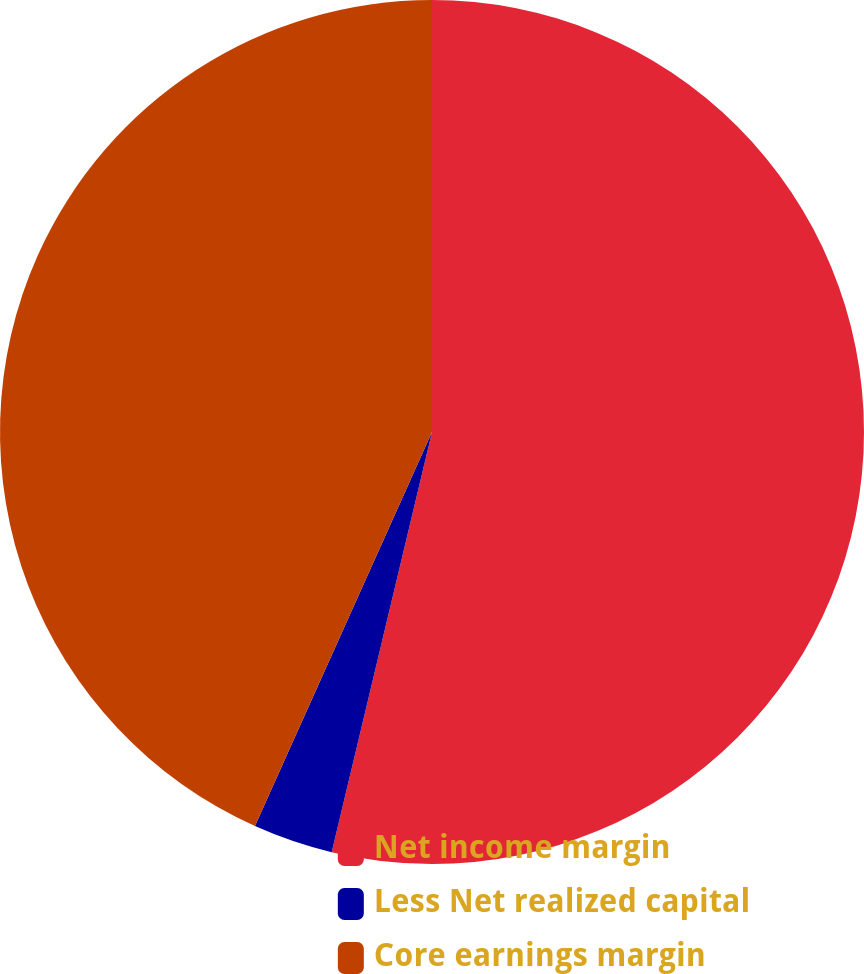<chart> <loc_0><loc_0><loc_500><loc_500><pie_chart><fcel>Net income margin<fcel>Less Net realized capital<fcel>Core earnings margin<nl><fcel>53.73%<fcel>2.99%<fcel>43.28%<nl></chart> 